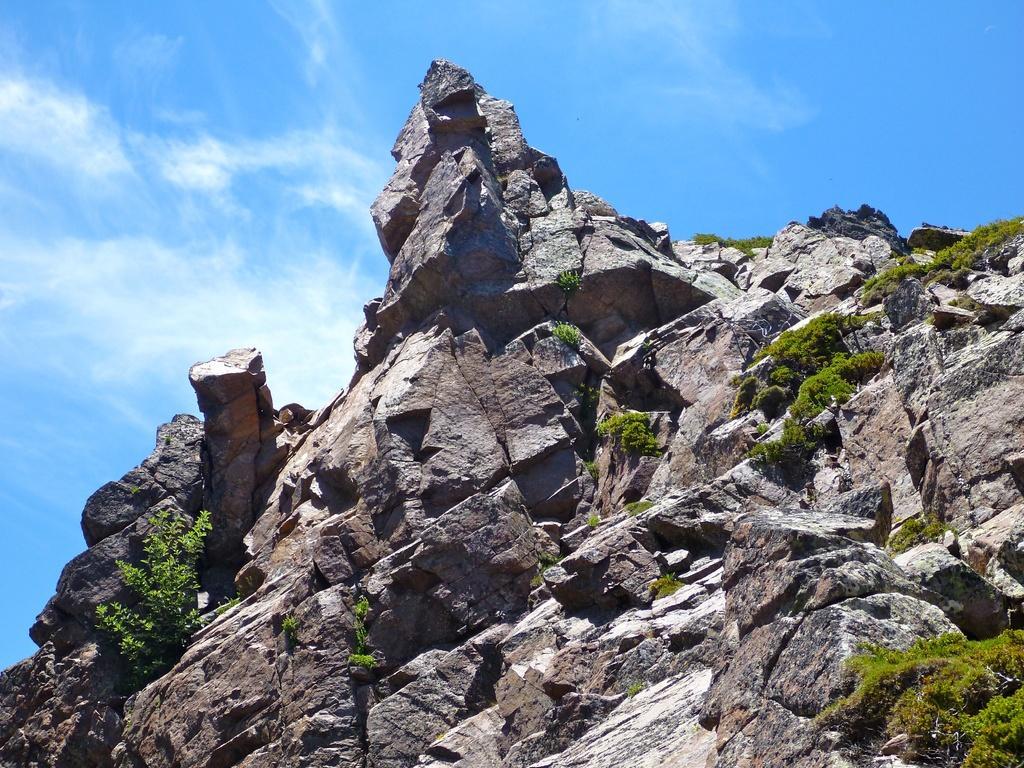Can you describe this image briefly? In the center of the image there is a rock with grass. At the top of the image there is sky. 